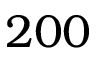Convert formula to latex. <formula><loc_0><loc_0><loc_500><loc_500>2 0 0</formula> 